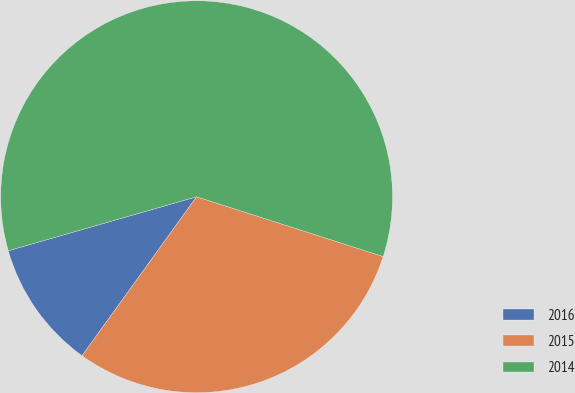<chart> <loc_0><loc_0><loc_500><loc_500><pie_chart><fcel>2016<fcel>2015<fcel>2014<nl><fcel>10.62%<fcel>30.0%<fcel>59.38%<nl></chart> 